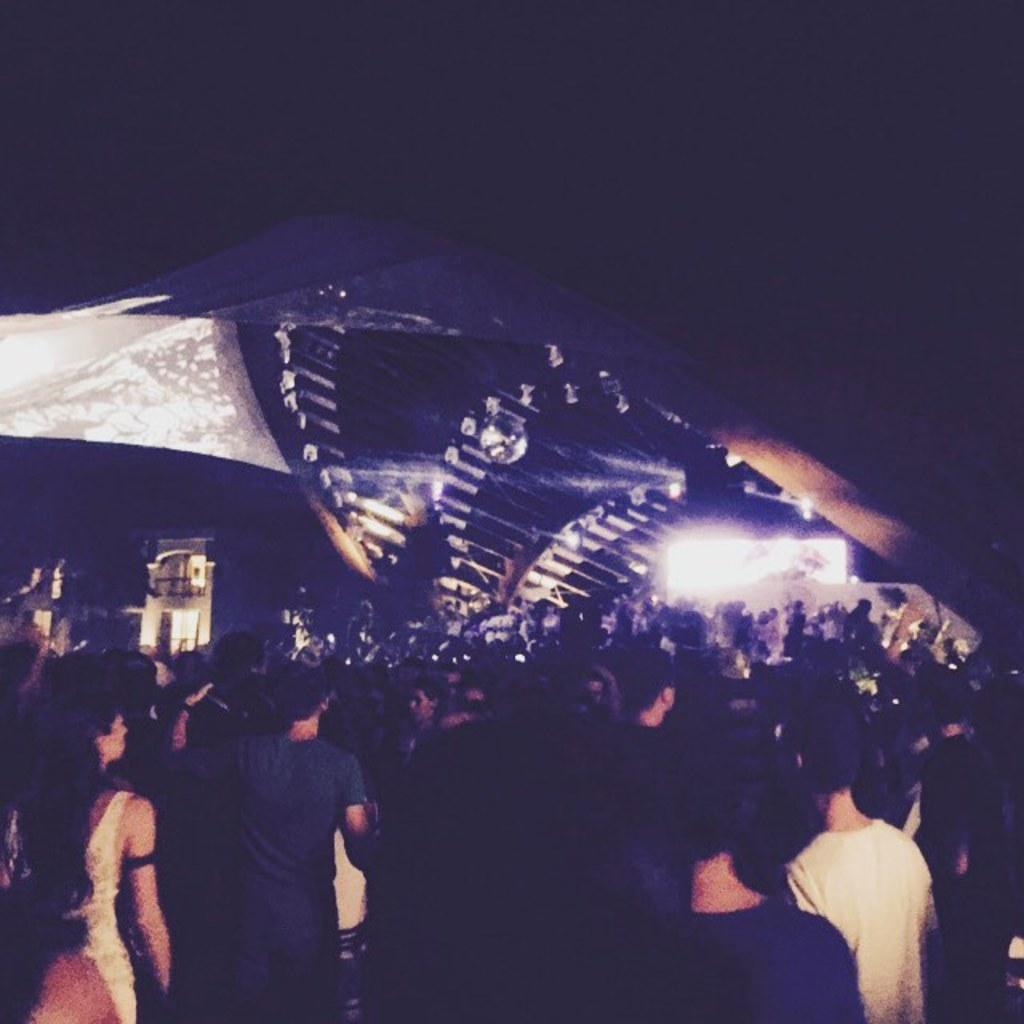What are the people in the image doing? The people in the image are standing on the ground. What is in front of the people? There is a big arch in front of the people. What else can be seen in the image besides the people and the arch? There are buildings visible in the image. How many fingers does the relation have in the image? There is no mention of a relation or fingers in the image; it only features people, an arch, and buildings. 